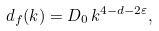<formula> <loc_0><loc_0><loc_500><loc_500>d _ { f } ( k ) = D _ { 0 } \, k ^ { 4 - d - 2 \varepsilon } ,</formula> 